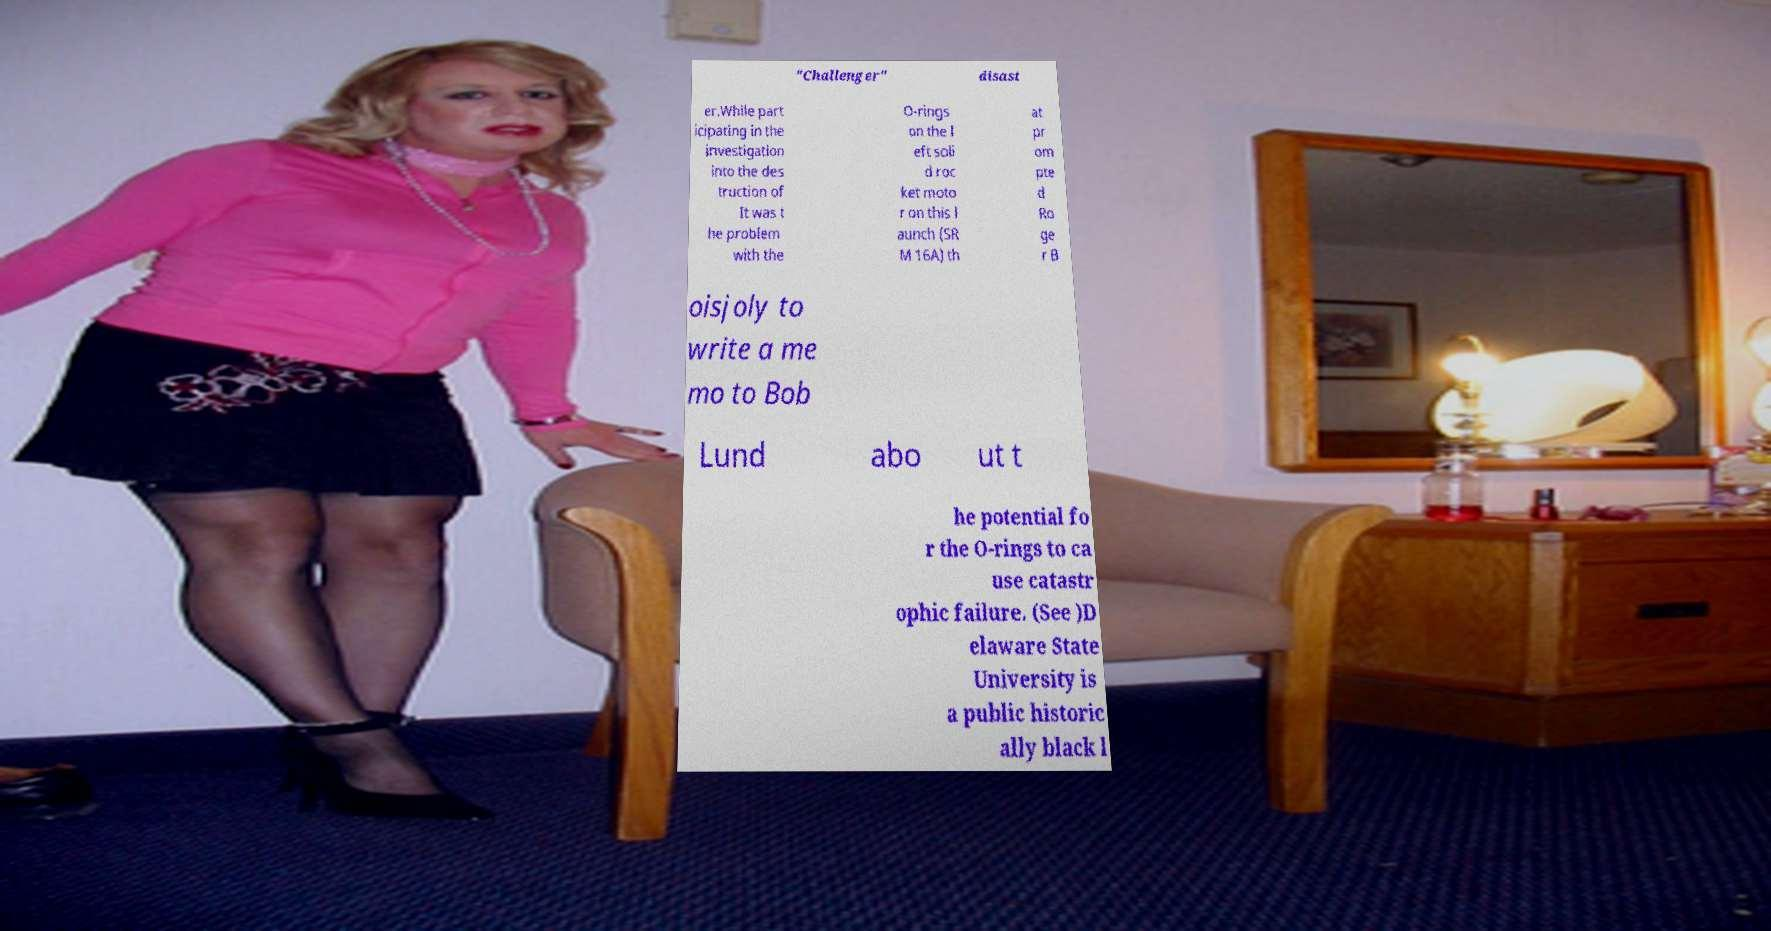What messages or text are displayed in this image? I need them in a readable, typed format. "Challenger" disast er.While part icipating in the investigation into the des truction of It was t he problem with the O-rings on the l eft soli d roc ket moto r on this l aunch (SR M 16A) th at pr om pte d Ro ge r B oisjoly to write a me mo to Bob Lund abo ut t he potential fo r the O-rings to ca use catastr ophic failure. (See )D elaware State University is a public historic ally black l 